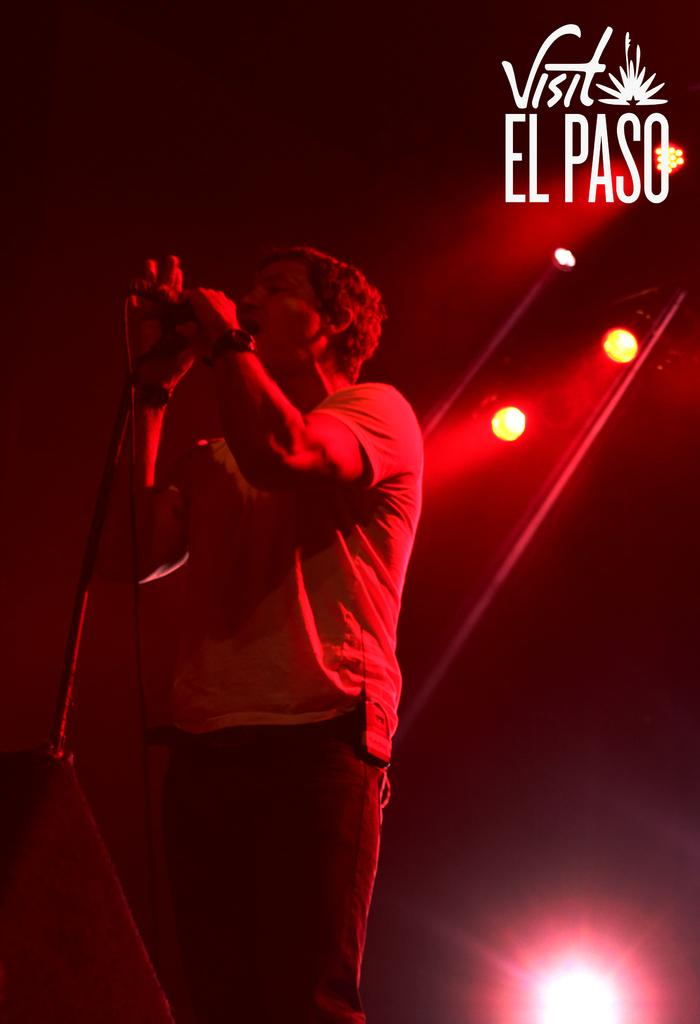What is the person in the image doing? The person is standing and holding a microphone. What can be seen in the background of the image? There are lights visible in the background. Is there any text present in the image? Yes, there is text present in the image. What type of pet can be seen playing with popcorn in the image? There is no pet or popcorn present in the image. How many boys are visible in the image? There is no mention of boys in the provided facts, so we cannot determine the number of boys in the image. 